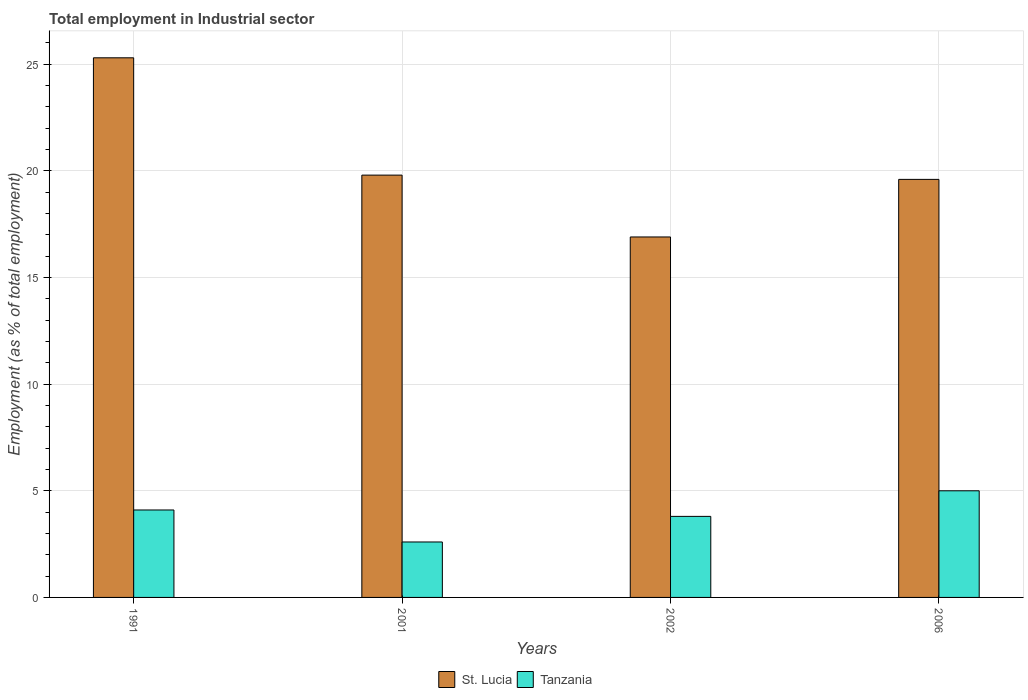How many groups of bars are there?
Provide a short and direct response. 4. Are the number of bars per tick equal to the number of legend labels?
Your answer should be very brief. Yes. How many bars are there on the 3rd tick from the left?
Provide a succinct answer. 2. How many bars are there on the 2nd tick from the right?
Your response must be concise. 2. What is the label of the 1st group of bars from the left?
Provide a succinct answer. 1991. What is the employment in industrial sector in St. Lucia in 2002?
Your answer should be compact. 16.9. Across all years, what is the maximum employment in industrial sector in Tanzania?
Keep it short and to the point. 5. Across all years, what is the minimum employment in industrial sector in St. Lucia?
Keep it short and to the point. 16.9. In which year was the employment in industrial sector in St. Lucia minimum?
Provide a succinct answer. 2002. What is the total employment in industrial sector in St. Lucia in the graph?
Provide a short and direct response. 81.6. What is the difference between the employment in industrial sector in Tanzania in 1991 and that in 2006?
Your answer should be very brief. -0.9. What is the difference between the employment in industrial sector in St. Lucia in 2001 and the employment in industrial sector in Tanzania in 2002?
Provide a succinct answer. 16. What is the average employment in industrial sector in St. Lucia per year?
Offer a very short reply. 20.4. In the year 2006, what is the difference between the employment in industrial sector in Tanzania and employment in industrial sector in St. Lucia?
Provide a succinct answer. -14.6. What is the ratio of the employment in industrial sector in Tanzania in 1991 to that in 2002?
Ensure brevity in your answer.  1.08. What is the difference between the highest and the second highest employment in industrial sector in Tanzania?
Give a very brief answer. 0.9. What is the difference between the highest and the lowest employment in industrial sector in St. Lucia?
Provide a succinct answer. 8.4. Is the sum of the employment in industrial sector in Tanzania in 2001 and 2002 greater than the maximum employment in industrial sector in St. Lucia across all years?
Your answer should be very brief. No. What does the 1st bar from the left in 1991 represents?
Give a very brief answer. St. Lucia. What does the 1st bar from the right in 2006 represents?
Ensure brevity in your answer.  Tanzania. Are all the bars in the graph horizontal?
Provide a short and direct response. No. Does the graph contain any zero values?
Your response must be concise. No. Does the graph contain grids?
Keep it short and to the point. Yes. Where does the legend appear in the graph?
Your answer should be very brief. Bottom center. How are the legend labels stacked?
Ensure brevity in your answer.  Horizontal. What is the title of the graph?
Ensure brevity in your answer.  Total employment in Industrial sector. Does "Fragile and conflict affected situations" appear as one of the legend labels in the graph?
Your response must be concise. No. What is the label or title of the Y-axis?
Ensure brevity in your answer.  Employment (as % of total employment). What is the Employment (as % of total employment) in St. Lucia in 1991?
Provide a short and direct response. 25.3. What is the Employment (as % of total employment) in Tanzania in 1991?
Provide a short and direct response. 4.1. What is the Employment (as % of total employment) of St. Lucia in 2001?
Offer a terse response. 19.8. What is the Employment (as % of total employment) of Tanzania in 2001?
Give a very brief answer. 2.6. What is the Employment (as % of total employment) in St. Lucia in 2002?
Offer a very short reply. 16.9. What is the Employment (as % of total employment) in Tanzania in 2002?
Provide a short and direct response. 3.8. What is the Employment (as % of total employment) in St. Lucia in 2006?
Provide a succinct answer. 19.6. Across all years, what is the maximum Employment (as % of total employment) in St. Lucia?
Your answer should be very brief. 25.3. Across all years, what is the maximum Employment (as % of total employment) of Tanzania?
Offer a very short reply. 5. Across all years, what is the minimum Employment (as % of total employment) in St. Lucia?
Ensure brevity in your answer.  16.9. Across all years, what is the minimum Employment (as % of total employment) in Tanzania?
Your answer should be compact. 2.6. What is the total Employment (as % of total employment) in St. Lucia in the graph?
Offer a very short reply. 81.6. What is the difference between the Employment (as % of total employment) in St. Lucia in 1991 and that in 2006?
Offer a very short reply. 5.7. What is the difference between the Employment (as % of total employment) in St. Lucia in 2001 and that in 2002?
Ensure brevity in your answer.  2.9. What is the difference between the Employment (as % of total employment) in Tanzania in 2001 and that in 2006?
Ensure brevity in your answer.  -2.4. What is the difference between the Employment (as % of total employment) of St. Lucia in 2002 and that in 2006?
Keep it short and to the point. -2.7. What is the difference between the Employment (as % of total employment) of Tanzania in 2002 and that in 2006?
Make the answer very short. -1.2. What is the difference between the Employment (as % of total employment) in St. Lucia in 1991 and the Employment (as % of total employment) in Tanzania in 2001?
Make the answer very short. 22.7. What is the difference between the Employment (as % of total employment) of St. Lucia in 1991 and the Employment (as % of total employment) of Tanzania in 2002?
Provide a short and direct response. 21.5. What is the difference between the Employment (as % of total employment) of St. Lucia in 1991 and the Employment (as % of total employment) of Tanzania in 2006?
Make the answer very short. 20.3. What is the average Employment (as % of total employment) of St. Lucia per year?
Your response must be concise. 20.4. What is the average Employment (as % of total employment) of Tanzania per year?
Your response must be concise. 3.88. In the year 1991, what is the difference between the Employment (as % of total employment) in St. Lucia and Employment (as % of total employment) in Tanzania?
Your answer should be very brief. 21.2. In the year 2002, what is the difference between the Employment (as % of total employment) in St. Lucia and Employment (as % of total employment) in Tanzania?
Your answer should be compact. 13.1. In the year 2006, what is the difference between the Employment (as % of total employment) in St. Lucia and Employment (as % of total employment) in Tanzania?
Your answer should be compact. 14.6. What is the ratio of the Employment (as % of total employment) in St. Lucia in 1991 to that in 2001?
Your answer should be compact. 1.28. What is the ratio of the Employment (as % of total employment) of Tanzania in 1991 to that in 2001?
Keep it short and to the point. 1.58. What is the ratio of the Employment (as % of total employment) of St. Lucia in 1991 to that in 2002?
Keep it short and to the point. 1.5. What is the ratio of the Employment (as % of total employment) in Tanzania in 1991 to that in 2002?
Make the answer very short. 1.08. What is the ratio of the Employment (as % of total employment) in St. Lucia in 1991 to that in 2006?
Your answer should be compact. 1.29. What is the ratio of the Employment (as % of total employment) in Tanzania in 1991 to that in 2006?
Your answer should be compact. 0.82. What is the ratio of the Employment (as % of total employment) of St. Lucia in 2001 to that in 2002?
Offer a very short reply. 1.17. What is the ratio of the Employment (as % of total employment) in Tanzania in 2001 to that in 2002?
Keep it short and to the point. 0.68. What is the ratio of the Employment (as % of total employment) of St. Lucia in 2001 to that in 2006?
Provide a short and direct response. 1.01. What is the ratio of the Employment (as % of total employment) of Tanzania in 2001 to that in 2006?
Give a very brief answer. 0.52. What is the ratio of the Employment (as % of total employment) in St. Lucia in 2002 to that in 2006?
Your response must be concise. 0.86. What is the ratio of the Employment (as % of total employment) in Tanzania in 2002 to that in 2006?
Offer a very short reply. 0.76. What is the difference between the highest and the second highest Employment (as % of total employment) of Tanzania?
Your response must be concise. 0.9. What is the difference between the highest and the lowest Employment (as % of total employment) of Tanzania?
Offer a terse response. 2.4. 